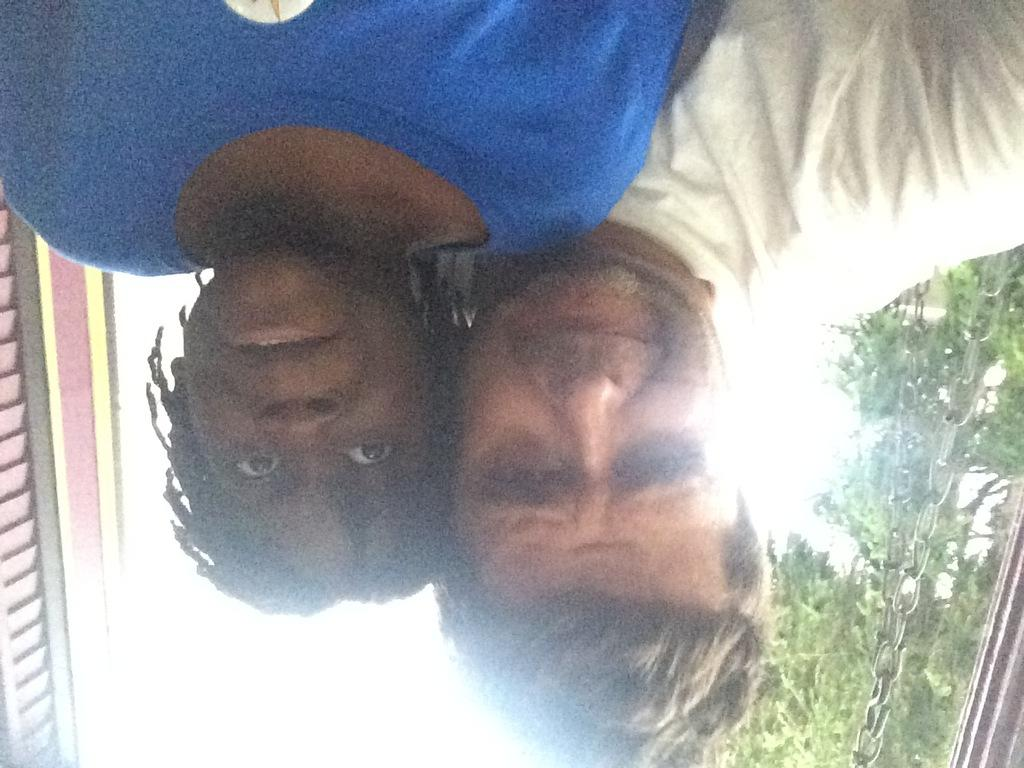How many people are in the image? There are two people in the image. What is on the right side of the people? There are chains on the right side of the people. What can be seen in the background of the image? There are trees and the sky visible in the background of the image. What type of cobweb can be seen on the left side of the people? There is no cobweb present on the left side of the people in the image. 